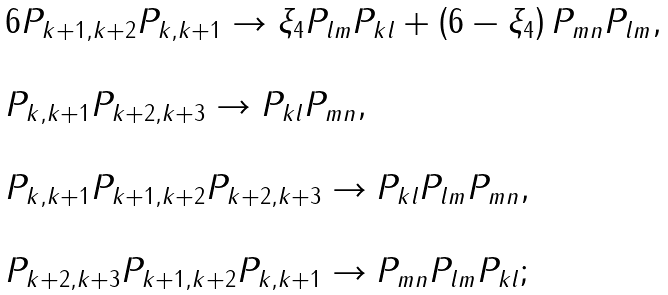Convert formula to latex. <formula><loc_0><loc_0><loc_500><loc_500>\begin{array} { l } 6 P _ { k + 1 , k + 2 } P _ { k , k + 1 } \rightarrow \xi _ { 4 } P _ { l m } P _ { k l } + \left ( 6 - \xi _ { 4 } \right ) P _ { m n } P _ { l m } , \\ \\ P _ { k , k + 1 } P _ { k + 2 , k + 3 } \rightarrow P _ { k l } P _ { m n } , \\ \\ P _ { k , k + 1 } P _ { k + 1 , k + 2 } P _ { k + 2 , k + 3 } \rightarrow P _ { k l } P _ { l m } P _ { m n } , \\ \\ P _ { k + 2 , k + 3 } P _ { k + 1 , k + 2 } P _ { k , k + 1 } \rightarrow P _ { m n } P _ { l m } P _ { k l } ; \end{array}</formula> 